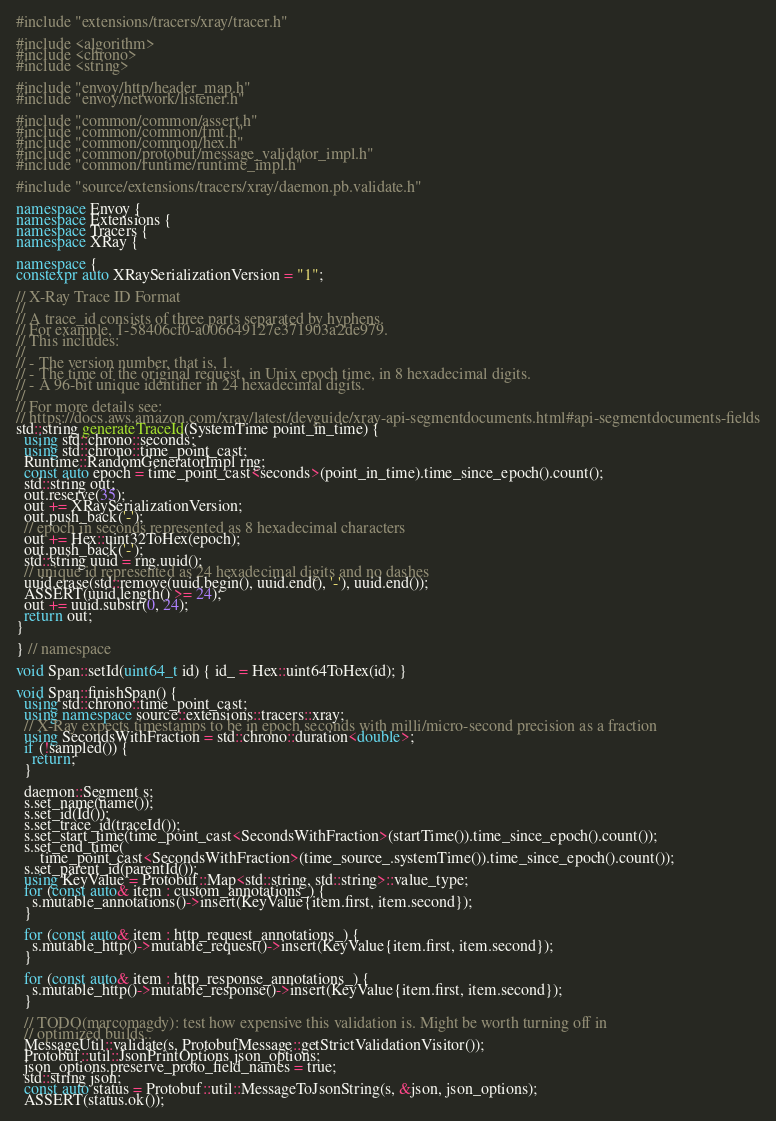<code> <loc_0><loc_0><loc_500><loc_500><_C++_>#include "extensions/tracers/xray/tracer.h"

#include <algorithm>
#include <chrono>
#include <string>

#include "envoy/http/header_map.h"
#include "envoy/network/listener.h"

#include "common/common/assert.h"
#include "common/common/fmt.h"
#include "common/common/hex.h"
#include "common/protobuf/message_validator_impl.h"
#include "common/runtime/runtime_impl.h"

#include "source/extensions/tracers/xray/daemon.pb.validate.h"

namespace Envoy {
namespace Extensions {
namespace Tracers {
namespace XRay {

namespace {
constexpr auto XRaySerializationVersion = "1";

// X-Ray Trace ID Format
//
// A trace_id consists of three parts separated by hyphens.
// For example, 1-58406cf0-a006649127e371903a2de979.
// This includes:
//
// - The version number, that is, 1.
// - The time of the original request, in Unix epoch time, in 8 hexadecimal digits.
// - A 96-bit unique identifier in 24 hexadecimal digits.
//
// For more details see:
// https://docs.aws.amazon.com/xray/latest/devguide/xray-api-segmentdocuments.html#api-segmentdocuments-fields
std::string generateTraceId(SystemTime point_in_time) {
  using std::chrono::seconds;
  using std::chrono::time_point_cast;
  Runtime::RandomGeneratorImpl rng;
  const auto epoch = time_point_cast<seconds>(point_in_time).time_since_epoch().count();
  std::string out;
  out.reserve(35);
  out += XRaySerializationVersion;
  out.push_back('-');
  // epoch in seconds represented as 8 hexadecimal characters
  out += Hex::uint32ToHex(epoch);
  out.push_back('-');
  std::string uuid = rng.uuid();
  // unique id represented as 24 hexadecimal digits and no dashes
  uuid.erase(std::remove(uuid.begin(), uuid.end(), '-'), uuid.end());
  ASSERT(uuid.length() >= 24);
  out += uuid.substr(0, 24);
  return out;
}

} // namespace

void Span::setId(uint64_t id) { id_ = Hex::uint64ToHex(id); }

void Span::finishSpan() {
  using std::chrono::time_point_cast;
  using namespace source::extensions::tracers::xray;
  // X-Ray expects timestamps to be in epoch seconds with milli/micro-second precision as a fraction
  using SecondsWithFraction = std::chrono::duration<double>;
  if (!sampled()) {
    return;
  }

  daemon::Segment s;
  s.set_name(name());
  s.set_id(Id());
  s.set_trace_id(traceId());
  s.set_start_time(time_point_cast<SecondsWithFraction>(startTime()).time_since_epoch().count());
  s.set_end_time(
      time_point_cast<SecondsWithFraction>(time_source_.systemTime()).time_since_epoch().count());
  s.set_parent_id(parentId());
  using KeyValue = Protobuf::Map<std::string, std::string>::value_type;
  for (const auto& item : custom_annotations_) {
    s.mutable_annotations()->insert(KeyValue{item.first, item.second});
  }

  for (const auto& item : http_request_annotations_) {
    s.mutable_http()->mutable_request()->insert(KeyValue{item.first, item.second});
  }

  for (const auto& item : http_response_annotations_) {
    s.mutable_http()->mutable_response()->insert(KeyValue{item.first, item.second});
  }

  // TODO(marcomagdy): test how expensive this validation is. Might be worth turning off in
  // optimized builds..
  MessageUtil::validate(s, ProtobufMessage::getStrictValidationVisitor());
  Protobuf::util::JsonPrintOptions json_options;
  json_options.preserve_proto_field_names = true;
  std::string json;
  const auto status = Protobuf::util::MessageToJsonString(s, &json, json_options);
  ASSERT(status.ok());</code> 